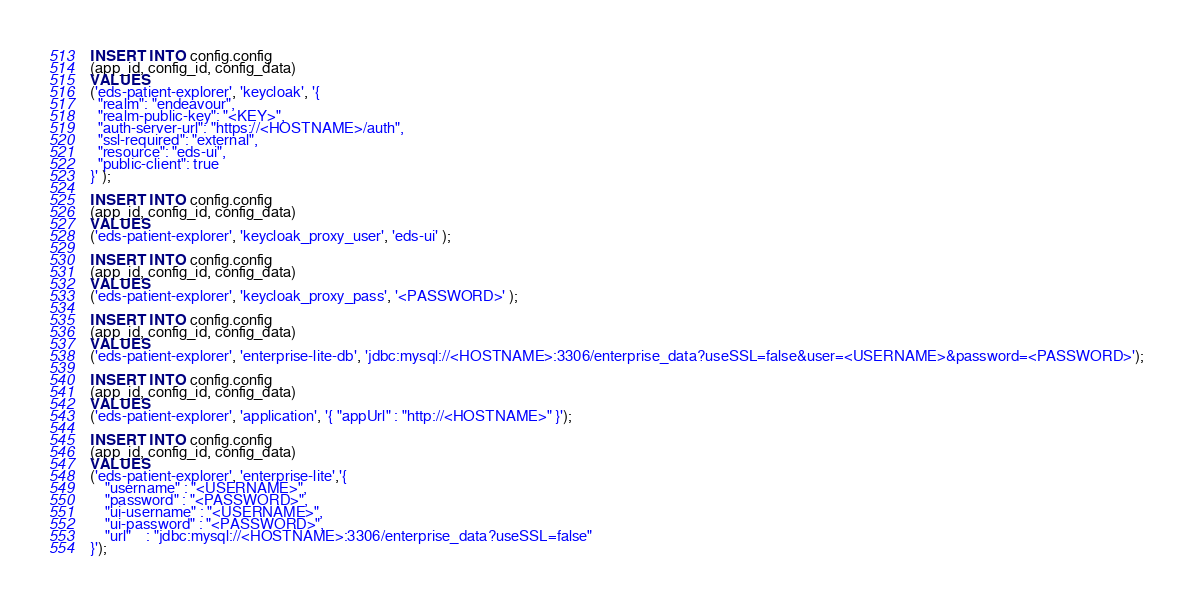Convert code to text. <code><loc_0><loc_0><loc_500><loc_500><_SQL_>INSERT INTO config.config
(app_id, config_id, config_data)
VALUES
('eds-patient-explorer', 'keycloak', '{
  "realm": "endeavour",
  "realm-public-key": "<KEY>",
  "auth-server-url": "https://<HOSTNAME>/auth",
  "ssl-required": "external",
  "resource": "eds-ui",
  "public-client": true
}' );

INSERT INTO config.config
(app_id, config_id, config_data)
VALUES
('eds-patient-explorer', 'keycloak_proxy_user', 'eds-ui' );

INSERT INTO config.config
(app_id, config_id, config_data)
VALUES
('eds-patient-explorer', 'keycloak_proxy_pass', '<PASSWORD>' );

INSERT INTO config.config
(app_id, config_id, config_data)
VALUES
('eds-patient-explorer', 'enterprise-lite-db', 'jdbc:mysql://<HOSTNAME>:3306/enterprise_data?useSSL=false&user=<USERNAME>&password=<PASSWORD>');

INSERT INTO config.config
(app_id, config_id, config_data)
VALUES
('eds-patient-explorer', 'application', '{ "appUrl" : "http://<HOSTNAME>" }');

INSERT INTO config.config
(app_id, config_id, config_data)
VALUES
('eds-patient-explorer', 'enterprise-lite','{
    "username" : "<USERNAME>",
    "password" : "<PASSWORD>",
    "ui-username" : "<USERNAME>",
    "ui-password" : "<PASSWORD>",
    "url"    : "jdbc:mysql://<HOSTNAME>:3306/enterprise_data?useSSL=false"
}');</code> 